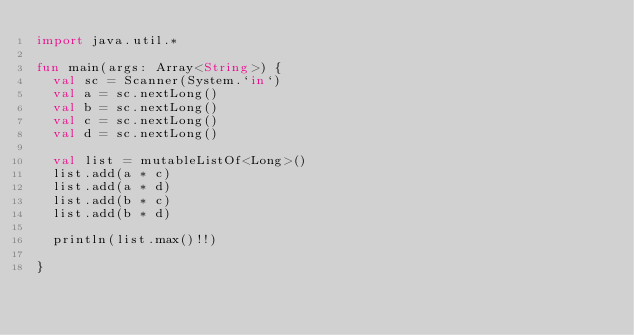Convert code to text. <code><loc_0><loc_0><loc_500><loc_500><_Kotlin_>import java.util.*

fun main(args: Array<String>) {
  val sc = Scanner(System.`in`)
  val a = sc.nextLong()
  val b = sc.nextLong()
  val c = sc.nextLong()
  val d = sc.nextLong()

  val list = mutableListOf<Long>()
  list.add(a * c)
  list.add(a * d)
  list.add(b * c)
  list.add(b * d)

  println(list.max()!!)

}
</code> 